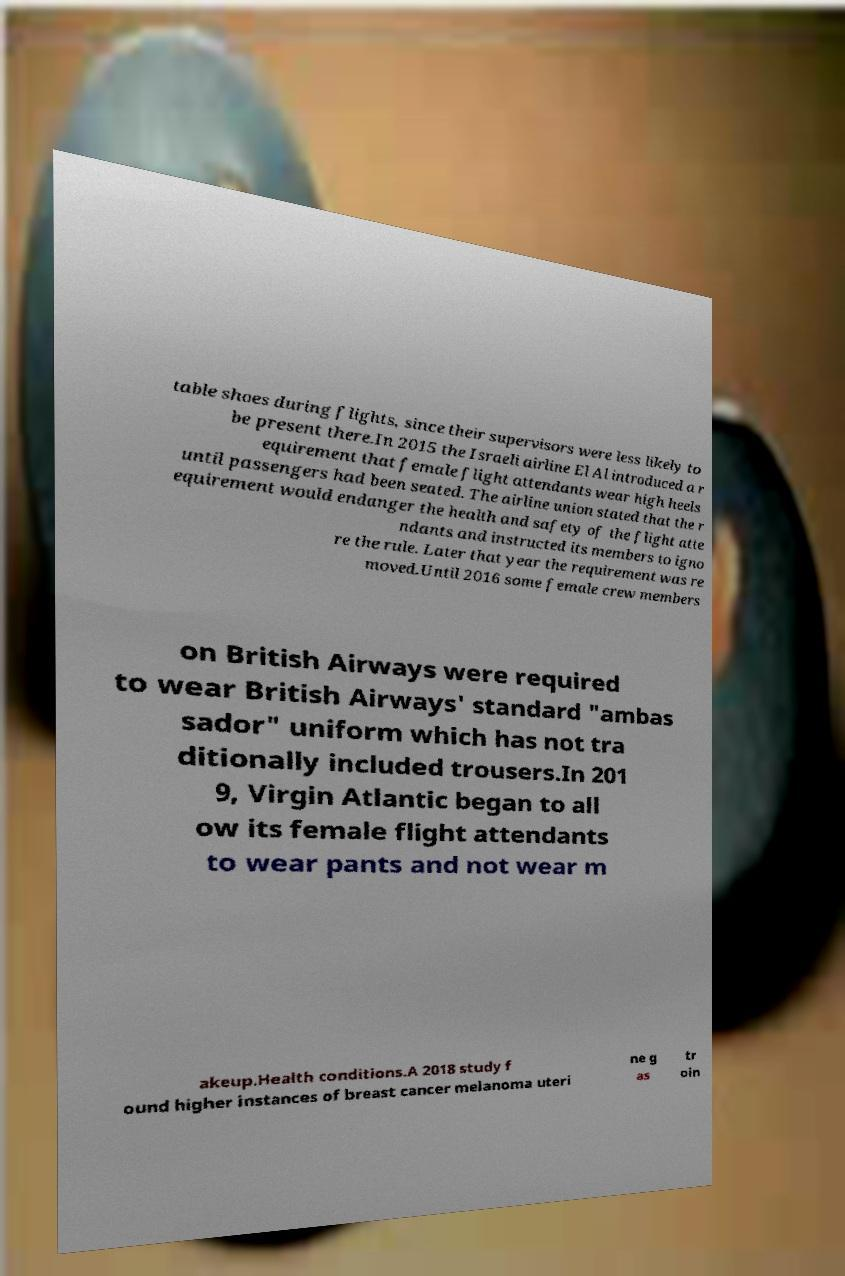Could you assist in decoding the text presented in this image and type it out clearly? table shoes during flights, since their supervisors were less likely to be present there.In 2015 the Israeli airline El Al introduced a r equirement that female flight attendants wear high heels until passengers had been seated. The airline union stated that the r equirement would endanger the health and safety of the flight atte ndants and instructed its members to igno re the rule. Later that year the requirement was re moved.Until 2016 some female crew members on British Airways were required to wear British Airways' standard "ambas sador" uniform which has not tra ditionally included trousers.In 201 9, Virgin Atlantic began to all ow its female flight attendants to wear pants and not wear m akeup.Health conditions.A 2018 study f ound higher instances of breast cancer melanoma uteri ne g as tr oin 